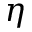Convert formula to latex. <formula><loc_0><loc_0><loc_500><loc_500>\eta</formula> 